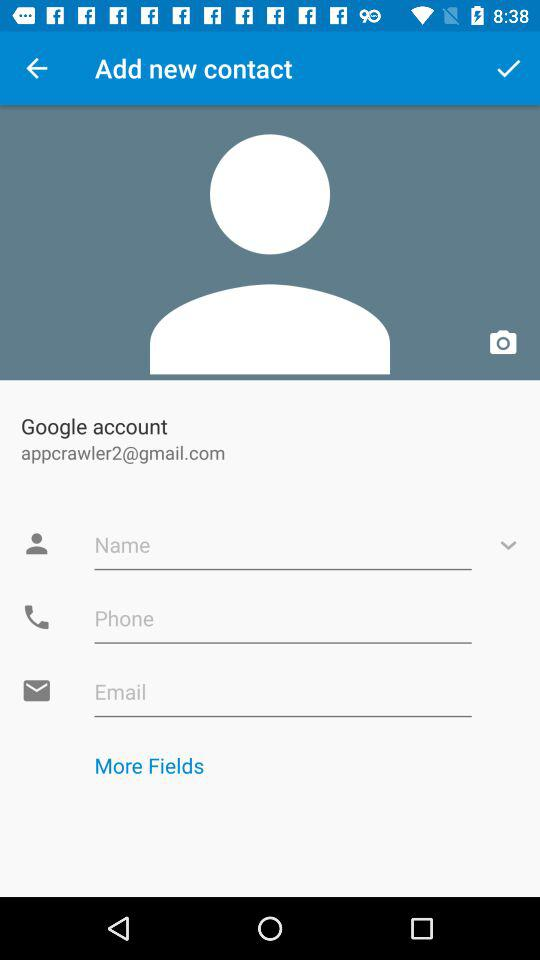What's the Google mail address used for the Google account? The Google mail address is appcrawler2@gmail.com. 